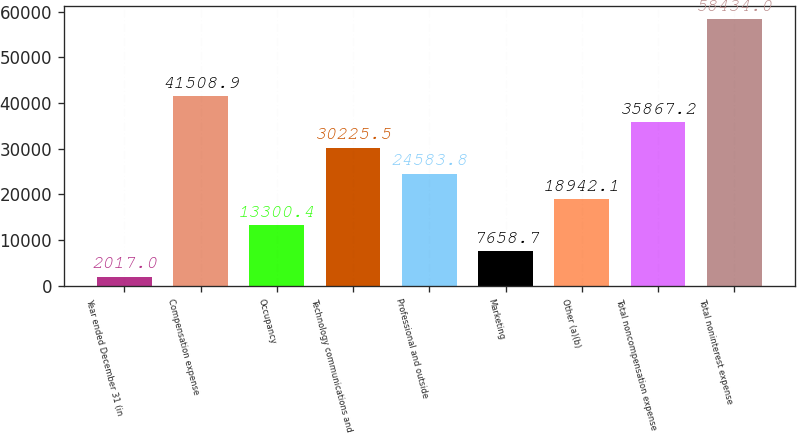Convert chart. <chart><loc_0><loc_0><loc_500><loc_500><bar_chart><fcel>Year ended December 31 (in<fcel>Compensation expense<fcel>Occupancy<fcel>Technology communications and<fcel>Professional and outside<fcel>Marketing<fcel>Other (a)(b)<fcel>Total noncompensation expense<fcel>Total noninterest expense<nl><fcel>2017<fcel>41508.9<fcel>13300.4<fcel>30225.5<fcel>24583.8<fcel>7658.7<fcel>18942.1<fcel>35867.2<fcel>58434<nl></chart> 